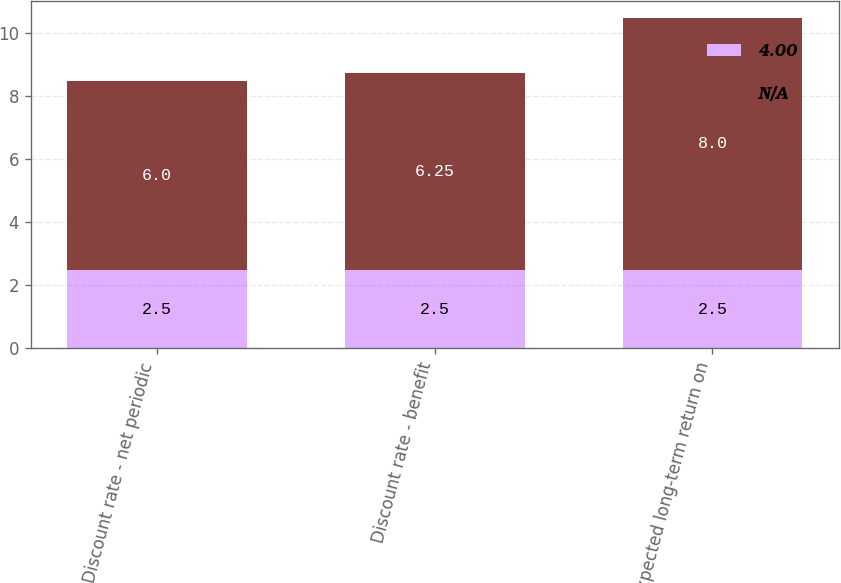Convert chart. <chart><loc_0><loc_0><loc_500><loc_500><stacked_bar_chart><ecel><fcel>Discount rate - net periodic<fcel>Discount rate - benefit<fcel>Expected long-term return on<nl><fcel>4<fcel>2.5<fcel>2.5<fcel>2.5<nl><fcel>nan<fcel>6<fcel>6.25<fcel>8<nl></chart> 